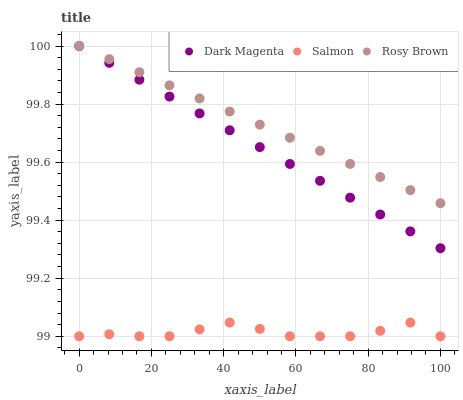Does Salmon have the minimum area under the curve?
Answer yes or no. Yes. Does Rosy Brown have the maximum area under the curve?
Answer yes or no. Yes. Does Dark Magenta have the minimum area under the curve?
Answer yes or no. No. Does Dark Magenta have the maximum area under the curve?
Answer yes or no. No. Is Rosy Brown the smoothest?
Answer yes or no. Yes. Is Salmon the roughest?
Answer yes or no. Yes. Is Dark Magenta the smoothest?
Answer yes or no. No. Is Dark Magenta the roughest?
Answer yes or no. No. Does Salmon have the lowest value?
Answer yes or no. Yes. Does Dark Magenta have the lowest value?
Answer yes or no. No. Does Dark Magenta have the highest value?
Answer yes or no. Yes. Does Salmon have the highest value?
Answer yes or no. No. Is Salmon less than Dark Magenta?
Answer yes or no. Yes. Is Dark Magenta greater than Salmon?
Answer yes or no. Yes. Does Rosy Brown intersect Dark Magenta?
Answer yes or no. Yes. Is Rosy Brown less than Dark Magenta?
Answer yes or no. No. Is Rosy Brown greater than Dark Magenta?
Answer yes or no. No. Does Salmon intersect Dark Magenta?
Answer yes or no. No. 